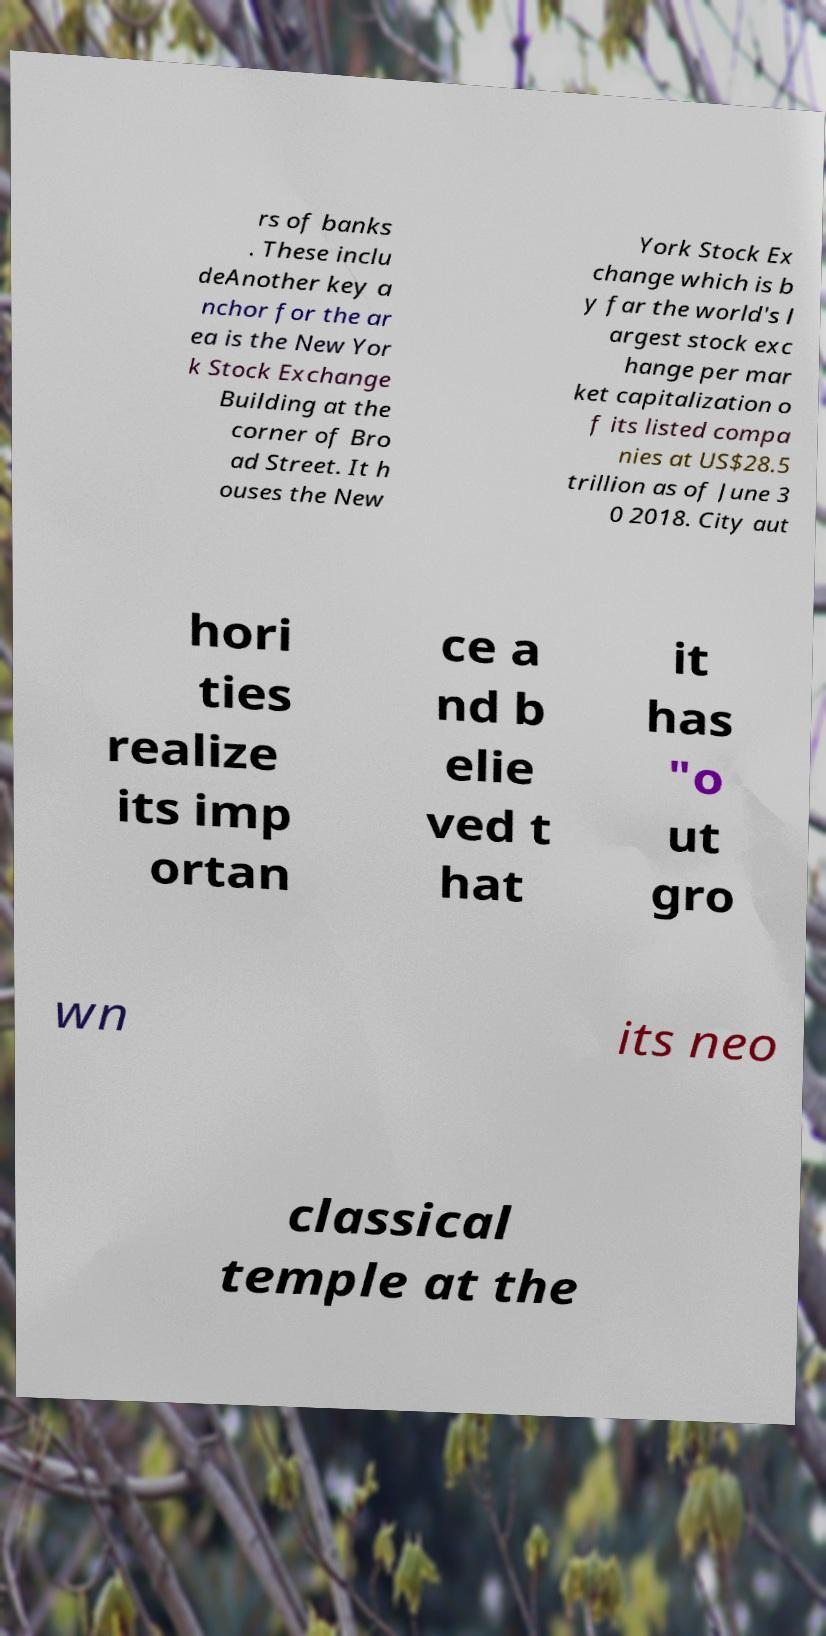Please read and relay the text visible in this image. What does it say? rs of banks . These inclu deAnother key a nchor for the ar ea is the New Yor k Stock Exchange Building at the corner of Bro ad Street. It h ouses the New York Stock Ex change which is b y far the world's l argest stock exc hange per mar ket capitalization o f its listed compa nies at US$28.5 trillion as of June 3 0 2018. City aut hori ties realize its imp ortan ce a nd b elie ved t hat it has "o ut gro wn its neo classical temple at the 